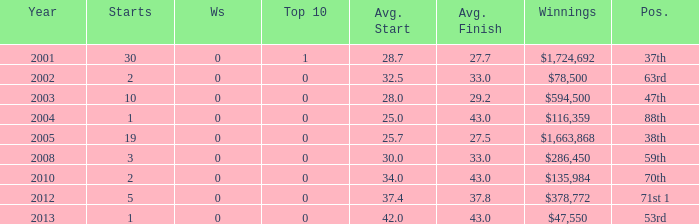What is the average top 10 score for 2 starts, winnings of $135,984 and an average finish more than 43? None. Could you parse the entire table? {'header': ['Year', 'Starts', 'Ws', 'Top 10', 'Avg. Start', 'Avg. Finish', 'Winnings', 'Pos.'], 'rows': [['2001', '30', '0', '1', '28.7', '27.7', '$1,724,692', '37th'], ['2002', '2', '0', '0', '32.5', '33.0', '$78,500', '63rd'], ['2003', '10', '0', '0', '28.0', '29.2', '$594,500', '47th'], ['2004', '1', '0', '0', '25.0', '43.0', '$116,359', '88th'], ['2005', '19', '0', '0', '25.7', '27.5', '$1,663,868', '38th'], ['2008', '3', '0', '0', '30.0', '33.0', '$286,450', '59th'], ['2010', '2', '0', '0', '34.0', '43.0', '$135,984', '70th'], ['2012', '5', '0', '0', '37.4', '37.8', '$378,772', '71st 1'], ['2013', '1', '0', '0', '42.0', '43.0', '$47,550', '53rd']]} 